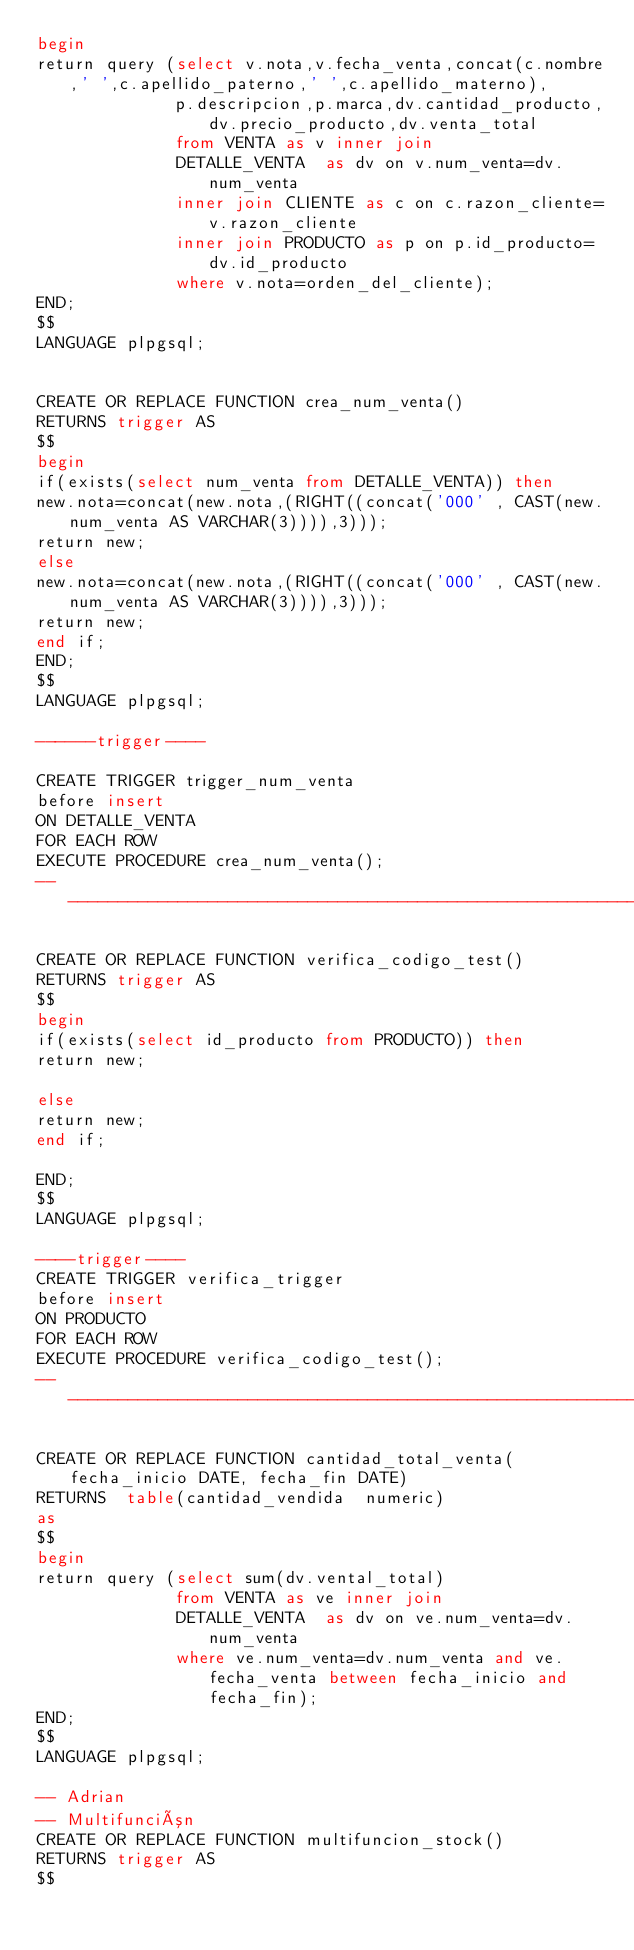<code> <loc_0><loc_0><loc_500><loc_500><_SQL_>begin
return query (select v.nota,v.fecha_venta,concat(c.nombre,' ',c.apellido_paterno,' ',c.apellido_materno),
              p.descripcion,p.marca,dv.cantidad_producto,dv.precio_producto,dv.venta_total
              from VENTA as v inner join
              DETALLE_VENTA  as dv on v.num_venta=dv.num_venta
              inner join CLIENTE as c on c.razon_cliente=v.razon_cliente
              inner join PRODUCTO as p on p.id_producto=dv.id_producto
              where v.nota=orden_del_cliente);
END;
$$
LANGUAGE plpgsql;


CREATE OR REPLACE FUNCTION crea_num_venta()
RETURNS trigger AS
$$
begin
if(exists(select num_venta from DETALLE_VENTA)) then
new.nota=concat(new.nota,(RIGHT((concat('000' , CAST(new.num_venta AS VARCHAR(3)))),3)));
return new;
else
new.nota=concat(new.nota,(RIGHT((concat('000' , CAST(new.num_venta AS VARCHAR(3)))),3)));
return new;
end if;
END;
$$
LANGUAGE plpgsql;

------trigger----

CREATE TRIGGER trigger_num_venta
before insert
ON DETALLE_VENTA
FOR EACH ROW
EXECUTE PROCEDURE crea_num_venta();
---------------------------------------------------------------------

CREATE OR REPLACE FUNCTION verifica_codigo_test()
RETURNS trigger AS
$$
begin
if(exists(select id_producto from PRODUCTO)) then
return new;

else
return new;
end if;

END;
$$
LANGUAGE plpgsql;

----trigger----
CREATE TRIGGER verifica_trigger
before insert
ON PRODUCTO
FOR EACH ROW
EXECUTE PROCEDURE verifica_codigo_test();
------------------------------------------------------------------------------------

CREATE OR REPLACE FUNCTION cantidad_total_venta(fecha_inicio DATE, fecha_fin DATE)
RETURNS  table(cantidad_vendida  numeric)
as
$$
begin
return query (select sum(dv.vental_total)
              from VENTA as ve inner join
              DETALLE_VENTA  as dv on ve.num_venta=dv.num_venta
              where ve.num_venta=dv.num_venta and ve.fecha_venta between fecha_inicio and fecha_fin);
END;
$$
LANGUAGE plpgsql;

-- Adrian
-- Multifunción
CREATE OR REPLACE FUNCTION multifuncion_stock()
RETURNS trigger AS
$$</code> 